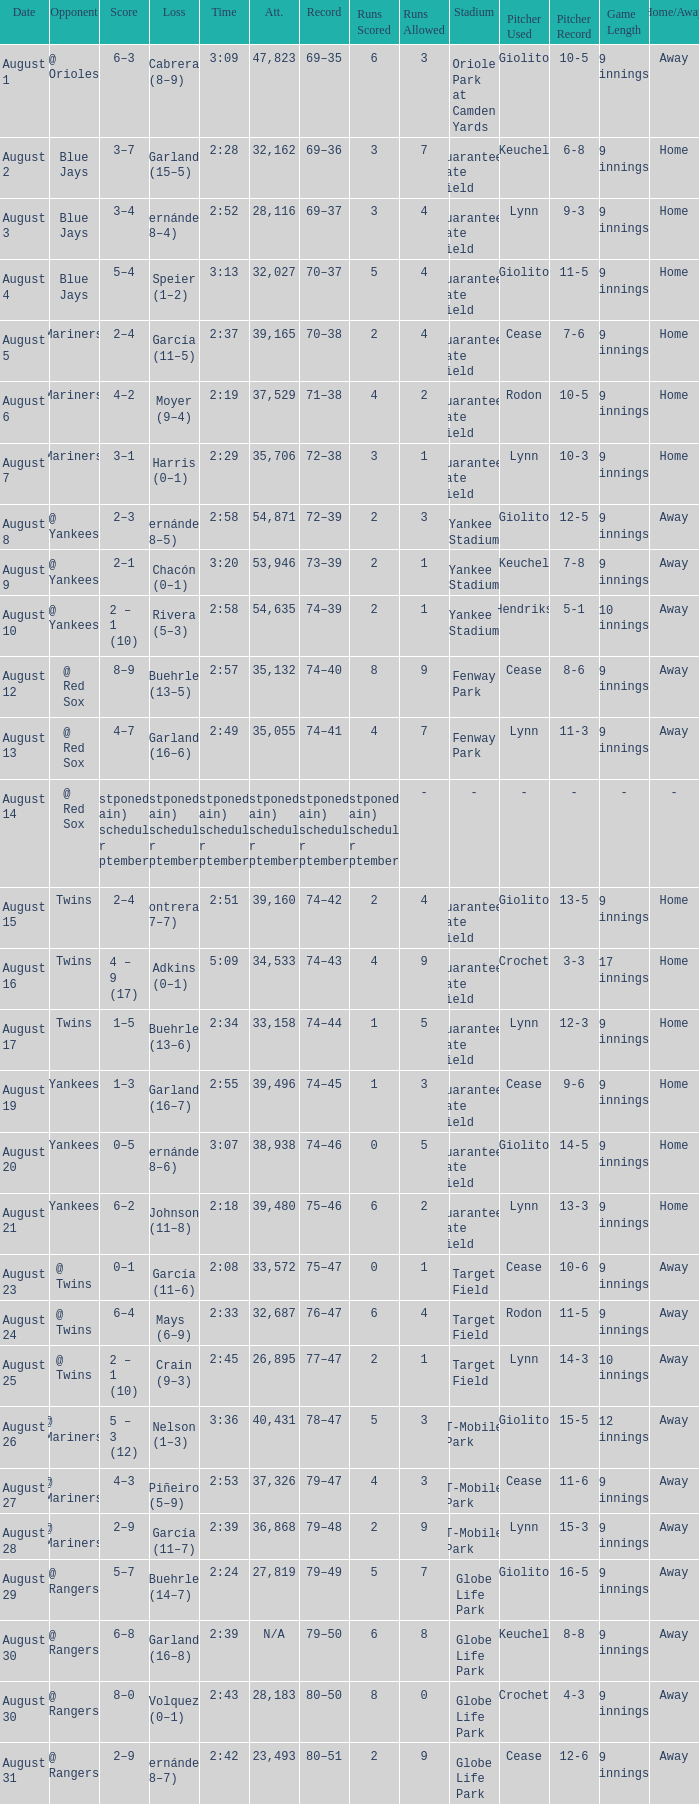Would you mind parsing the complete table? {'header': ['Date', 'Opponent', 'Score', 'Loss', 'Time', 'Att.', 'Record', 'Runs Scored', 'Runs Allowed', 'Stadium', 'Pitcher Used', 'Pitcher Record', 'Game Length', 'Home/Away'], 'rows': [['August 1', '@ Orioles', '6–3', 'Cabrera (8–9)', '3:09', '47,823', '69–35', '6', '3', 'Oriole Park at Camden Yards', 'Giolito', '10-5', '9 innings', 'Away'], ['August 2', 'Blue Jays', '3–7', 'Garland (15–5)', '2:28', '32,162', '69–36', '3', '7', 'Guaranteed Rate Field', 'Keuchel', '6-8', '9 innings', 'Home'], ['August 3', 'Blue Jays', '3–4', 'Hernández (8–4)', '2:52', '28,116', '69–37', '3', '4', 'Guaranteed Rate Field', 'Lynn', '9-3', '9 innings', 'Home'], ['August 4', 'Blue Jays', '5–4', 'Speier (1–2)', '3:13', '32,027', '70–37', '5', '4', 'Guaranteed Rate Field', 'Giolito', '11-5', '9 innings', 'Home'], ['August 5', 'Mariners', '2–4', 'García (11–5)', '2:37', '39,165', '70–38', '2', '4', 'Guaranteed Rate Field', 'Cease', '7-6', '9 innings', 'Home'], ['August 6', 'Mariners', '4–2', 'Moyer (9–4)', '2:19', '37,529', '71–38', '4', '2', 'Guaranteed Rate Field', 'Rodon', '10-5', '9 innings', 'Home'], ['August 7', 'Mariners', '3–1', 'Harris (0–1)', '2:29', '35,706', '72–38', '3', '1', 'Guaranteed Rate Field', 'Lynn', '10-3', '9 innings', 'Home'], ['August 8', '@ Yankees', '2–3', 'Hernández (8–5)', '2:58', '54,871', '72–39', '2', '3', 'Yankee Stadium', 'Giolito', '12-5', '9 innings', 'Away'], ['August 9', '@ Yankees', '2–1', 'Chacón (0–1)', '3:20', '53,946', '73–39', '2', '1', 'Yankee Stadium', 'Keuchel', '7-8', '9 innings', 'Away'], ['August 10', '@ Yankees', '2 – 1 (10)', 'Rivera (5–3)', '2:58', '54,635', '74–39', '2', '1', 'Yankee Stadium', 'Hendriks', '5-1', '10 innings', 'Away'], ['August 12', '@ Red Sox', '8–9', 'Buehrle (13–5)', '2:57', '35,132', '74–40', '8', '9', 'Fenway Park', 'Cease', '8-6', '9 innings', 'Away'], ['August 13', '@ Red Sox', '4–7', 'Garland (16–6)', '2:49', '35,055', '74–41', '4', '7', 'Fenway Park', 'Lynn', '11-3', '9 innings', 'Away'], ['August 14', '@ Red Sox', 'Postponed (rain) Rescheduled for September 5', 'Postponed (rain) Rescheduled for September 5', 'Postponed (rain) Rescheduled for September 5', 'Postponed (rain) Rescheduled for September 5', 'Postponed (rain) Rescheduled for September 5', 'Postponed (rain) Rescheduled for September 5', '-', '-', '-', '-', '-', '-'], ['August 15', 'Twins', '2–4', 'Contreras (7–7)', '2:51', '39,160', '74–42', '2', '4', 'Guaranteed Rate Field', 'Giolito', '13-5', '9 innings', 'Home'], ['August 16', 'Twins', '4 – 9 (17)', 'Adkins (0–1)', '5:09', '34,533', '74–43', '4', '9', 'Guaranteed Rate Field', 'Crochet', '3-3', '17 innings', 'Home'], ['August 17', 'Twins', '1–5', 'Buehrle (13–6)', '2:34', '33,158', '74–44', '1', '5', 'Guaranteed Rate Field', 'Lynn', '12-3', '9 innings', 'Home'], ['August 19', 'Yankees', '1–3', 'Garland (16–7)', '2:55', '39,496', '74–45', '1', '3', 'Guaranteed Rate Field', 'Cease', '9-6', '9 innings', 'Home'], ['August 20', 'Yankees', '0–5', 'Hernández (8–6)', '3:07', '38,938', '74–46', '0', '5', 'Guaranteed Rate Field', 'Giolito', '14-5', '9 innings', 'Home'], ['August 21', 'Yankees', '6–2', 'Johnson (11–8)', '2:18', '39,480', '75–46', '6', '2', 'Guaranteed Rate Field', 'Lynn', '13-3', '9 innings', 'Home'], ['August 23', '@ Twins', '0–1', 'García (11–6)', '2:08', '33,572', '75–47', '0', '1', 'Target Field', 'Cease', '10-6', '9 innings', 'Away'], ['August 24', '@ Twins', '6–4', 'Mays (6–9)', '2:33', '32,687', '76–47', '6', '4', 'Target Field', 'Rodon', '11-5', '9 innings', 'Away'], ['August 25', '@ Twins', '2 – 1 (10)', 'Crain (9–3)', '2:45', '26,895', '77–47', '2', '1', 'Target Field', 'Lynn', '14-3', '10 innings', 'Away'], ['August 26', '@ Mariners', '5 – 3 (12)', 'Nelson (1–3)', '3:36', '40,431', '78–47', '5', '3', 'T-Mobile Park', 'Giolito', '15-5', '12 innings', 'Away'], ['August 27', '@ Mariners', '4–3', 'Piñeiro (5–9)', '2:53', '37,326', '79–47', '4', '3', 'T-Mobile Park', 'Cease', '11-6', '9 innings', 'Away'], ['August 28', '@ Mariners', '2–9', 'García (11–7)', '2:39', '36,868', '79–48', '2', '9', 'T-Mobile Park', 'Lynn', '15-3', '9 innings', 'Away'], ['August 29', '@ Rangers', '5–7', 'Buehrle (14–7)', '2:24', '27,819', '79–49', '5', '7', 'Globe Life Park', 'Giolito', '16-5', '9 innings', 'Away'], ['August 30', '@ Rangers', '6–8', 'Garland (16–8)', '2:39', 'N/A', '79–50', '6', '8', 'Globe Life Park', 'Keuchel', '8-8', '9 innings', 'Away'], ['August 30', '@ Rangers', '8–0', 'Volquez (0–1)', '2:43', '28,183', '80–50', '8', '0', 'Globe Life Park', 'Crochet', '4-3', '9 innings', 'Away'], ['August 31', '@ Rangers', '2–9', 'Hernández (8–7)', '2:42', '23,493', '80–51', '2', '9', 'Globe Life Park', 'Cease', '12-6', '9 innings', 'Away']]} Who lost with a time of 2:42? Hernández (8–7). 